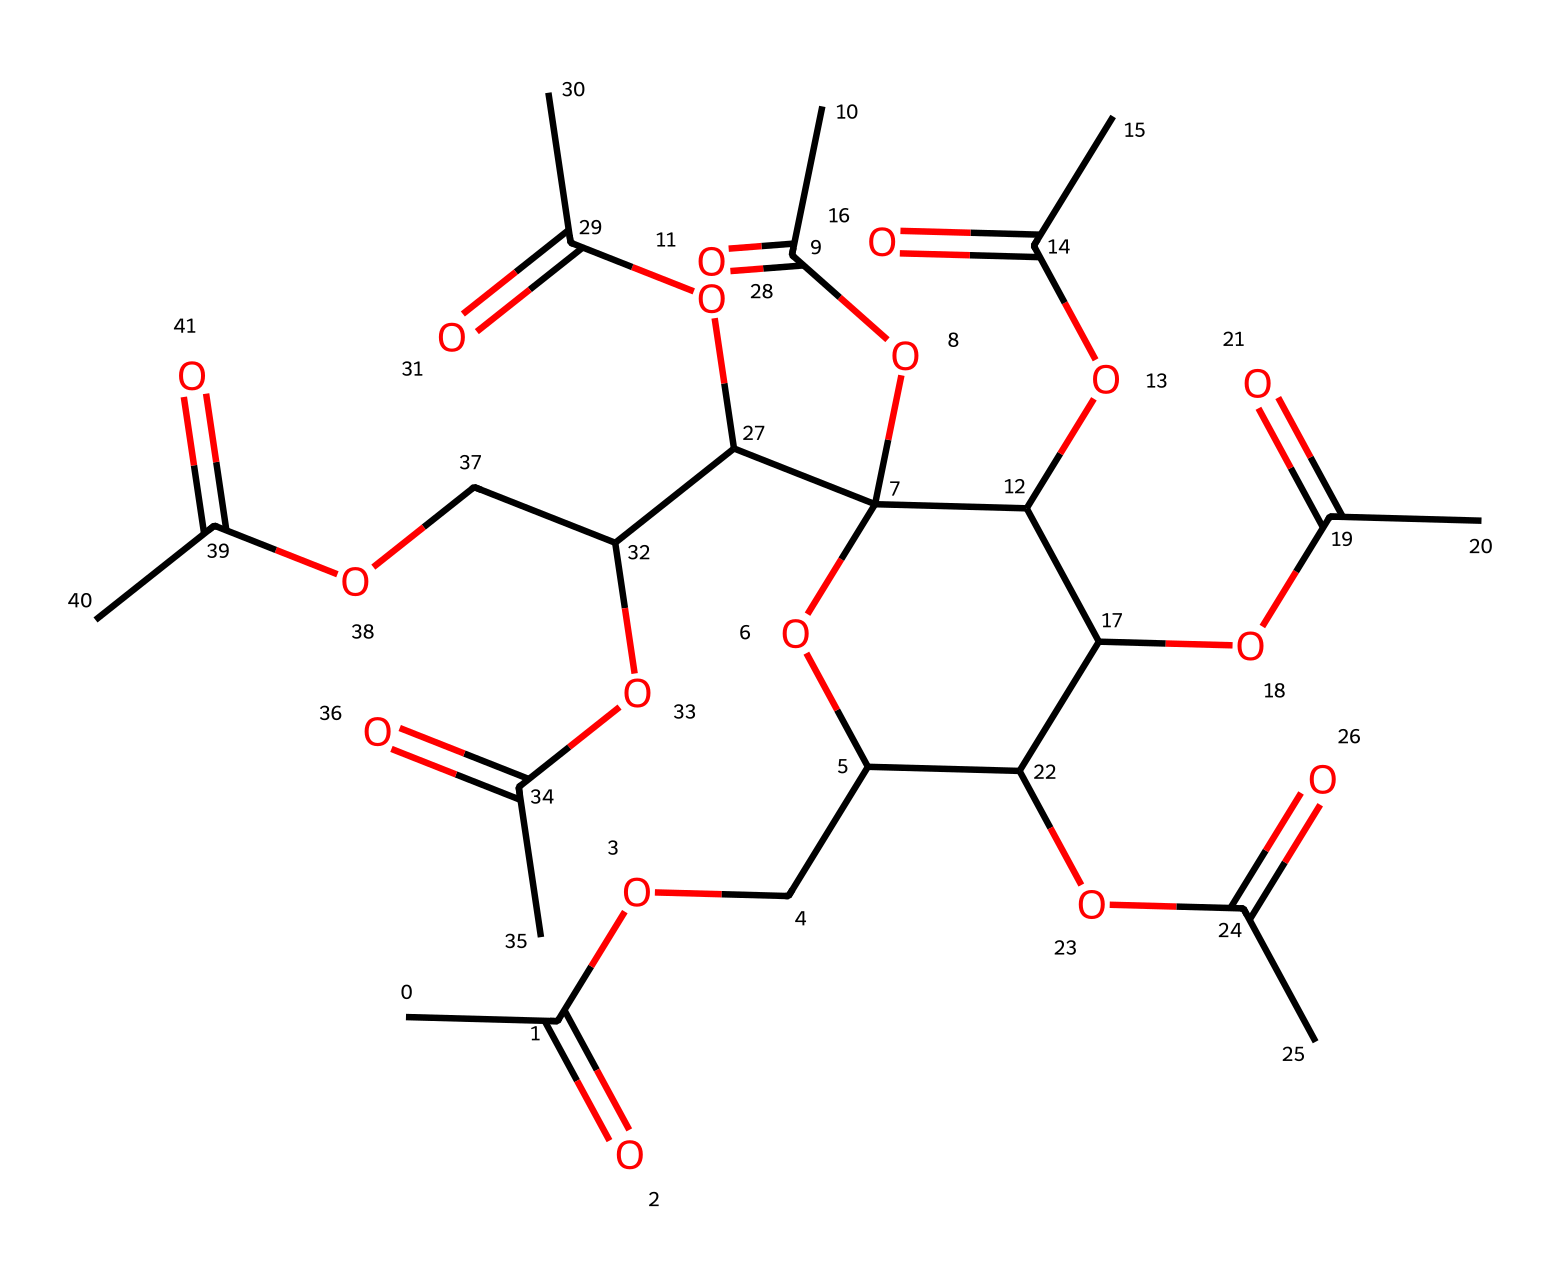How many carbon atoms are present in this molecule? To find the number of carbon atoms, we can identify the carbon atoms represented by the "C" in the SMILES notation before each atom. Counting the "C" yields a total of 16 carbon atoms in the structure.
Answer: 16 What is the primary functional group present in cellulose acetate? The presence of the “OCC(=O)” structure indicates the ester functional group, which is characteristic of cellulose acetate, as it consists of acetic acid derivatives.
Answer: ester How many ester linkages are present in the structure? Each “C(=O)O” represents an ester linkage. Counting the occurrences of "C(=O)O" yields a total of 5 ester linkages in the structure.
Answer: 5 What type of polymer is cellulose acetate classified as? Given that cellulose acetate is derived from cellulose through the formation of ester links, it is classified as a synthetic polymer resulting from the esterification of cellulose.
Answer: synthetic polymer What is the main application of cellulose acetate based on its structure? The structure of cellulose acetate, which provides flexibility and thermoplastic properties, indicates its primary application in textiles and packaging materials.
Answer: textiles and packaging materials 